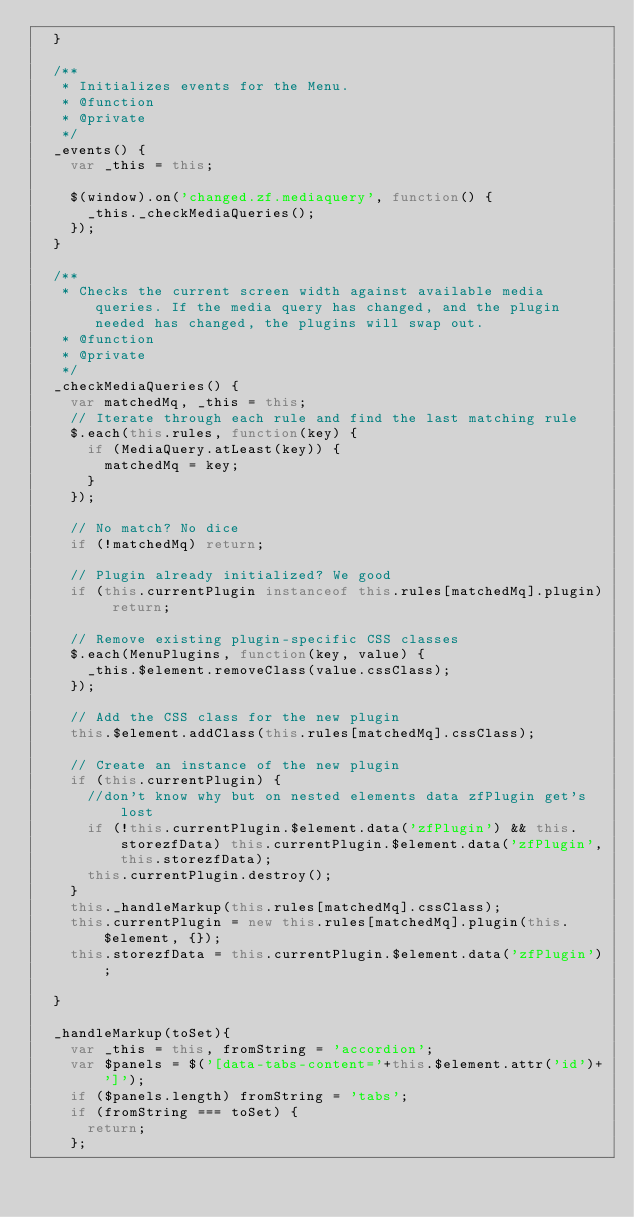Convert code to text. <code><loc_0><loc_0><loc_500><loc_500><_JavaScript_>  }

  /**
   * Initializes events for the Menu.
   * @function
   * @private
   */
  _events() {
    var _this = this;

    $(window).on('changed.zf.mediaquery', function() {
      _this._checkMediaQueries();
    });
  }

  /**
   * Checks the current screen width against available media queries. If the media query has changed, and the plugin needed has changed, the plugins will swap out.
   * @function
   * @private
   */
  _checkMediaQueries() {
    var matchedMq, _this = this;
    // Iterate through each rule and find the last matching rule
    $.each(this.rules, function(key) {
      if (MediaQuery.atLeast(key)) {
        matchedMq = key;
      }
    });

    // No match? No dice
    if (!matchedMq) return;

    // Plugin already initialized? We good
    if (this.currentPlugin instanceof this.rules[matchedMq].plugin) return;

    // Remove existing plugin-specific CSS classes
    $.each(MenuPlugins, function(key, value) {
      _this.$element.removeClass(value.cssClass);
    });

    // Add the CSS class for the new plugin
    this.$element.addClass(this.rules[matchedMq].cssClass);

    // Create an instance of the new plugin
    if (this.currentPlugin) {
      //don't know why but on nested elements data zfPlugin get's lost
      if (!this.currentPlugin.$element.data('zfPlugin') && this.storezfData) this.currentPlugin.$element.data('zfPlugin',this.storezfData);
      this.currentPlugin.destroy();
    }
    this._handleMarkup(this.rules[matchedMq].cssClass);
    this.currentPlugin = new this.rules[matchedMq].plugin(this.$element, {});
    this.storezfData = this.currentPlugin.$element.data('zfPlugin');

  }

  _handleMarkup(toSet){
    var _this = this, fromString = 'accordion';
    var $panels = $('[data-tabs-content='+this.$element.attr('id')+']');
    if ($panels.length) fromString = 'tabs';
    if (fromString === toSet) {
      return;
    };
</code> 